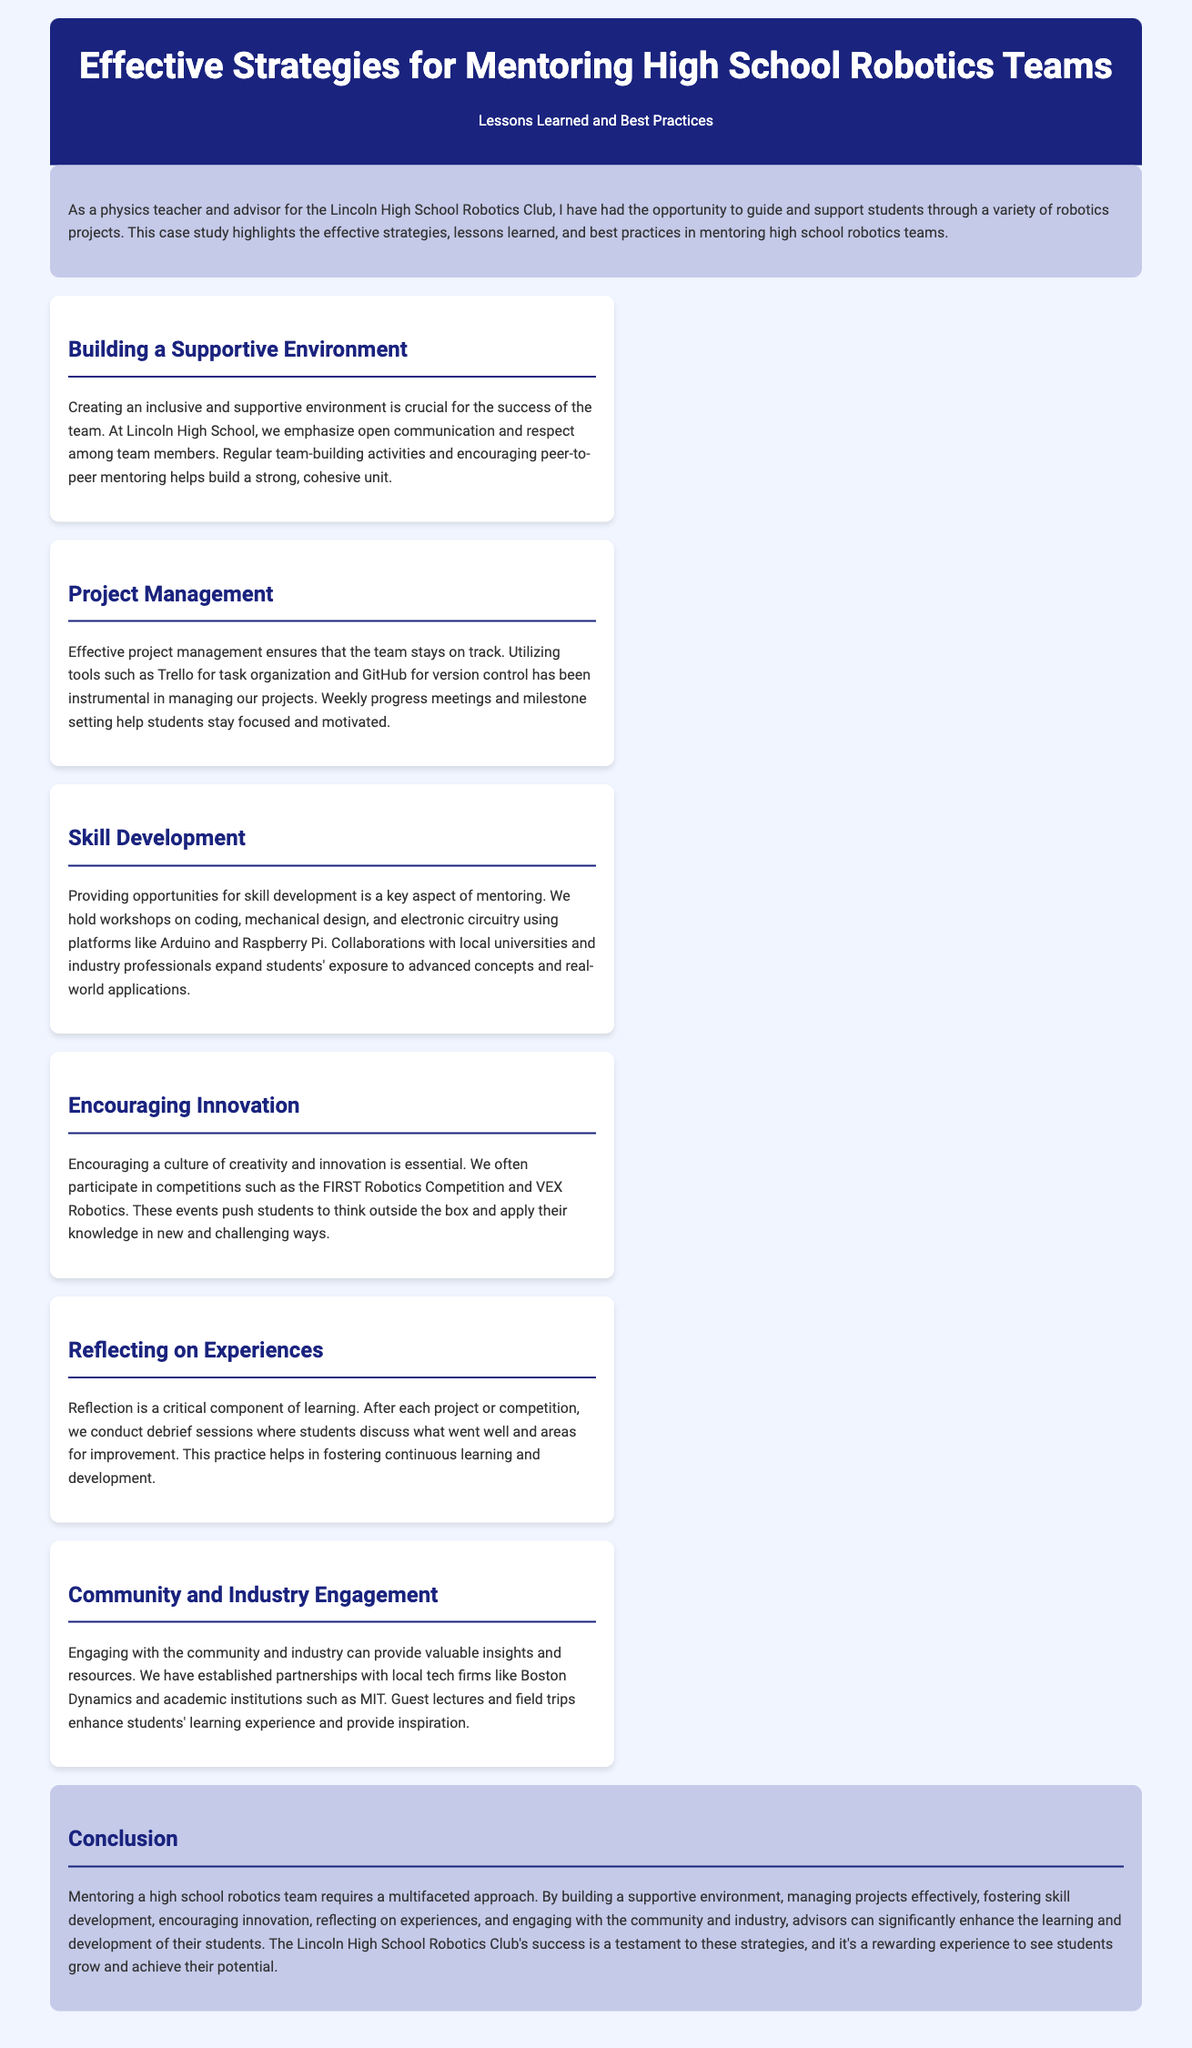What is the title of the case study? The title of the case study is provided at the top of the document.
Answer: Effective Strategies for Mentoring High School Robotics Teams What is one tool used for task organization in the project management section? The document mentions specific tools to assist with project management.
Answer: Trello Which activity helps build a cohesive team? The text describes a method to strengthen team unity and collaboration.
Answer: Team-building activities Name one type of workshop held for skill development. The document lists various areas where workshops are conducted for student learning.
Answer: Coding What is the purpose of reflection after each project? The text provides reasoning for conducting debrief sessions following projects or competitions.
Answer: Continuous learning Which competition do the students participate in to encourage innovation? The document mentions specific competitions that promote creativity and problem-solving among students.
Answer: FIRST Robotics Competition What local institution has established partnerships with the robotics club? The text lists collaborations that enhance students' learning experiences.
Answer: MIT How does engaging with the community benefit the students? The document outlines benefits gained from partnerships with local companies and educational institutions.
Answer: Valuable insights and resources 